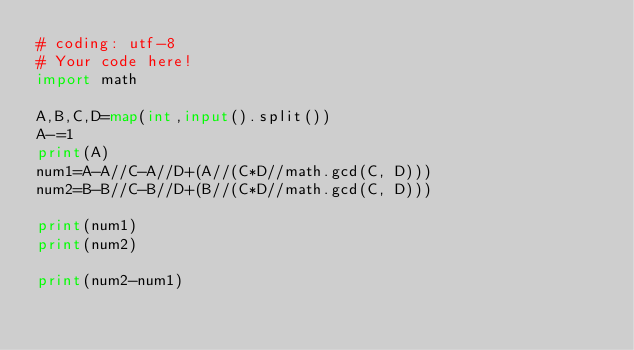Convert code to text. <code><loc_0><loc_0><loc_500><loc_500><_Python_># coding: utf-8
# Your code here!
import math

A,B,C,D=map(int,input().split())
A-=1
print(A)
num1=A-A//C-A//D+(A//(C*D//math.gcd(C, D)))
num2=B-B//C-B//D+(B//(C*D//math.gcd(C, D)))

print(num1)
print(num2)

print(num2-num1)</code> 